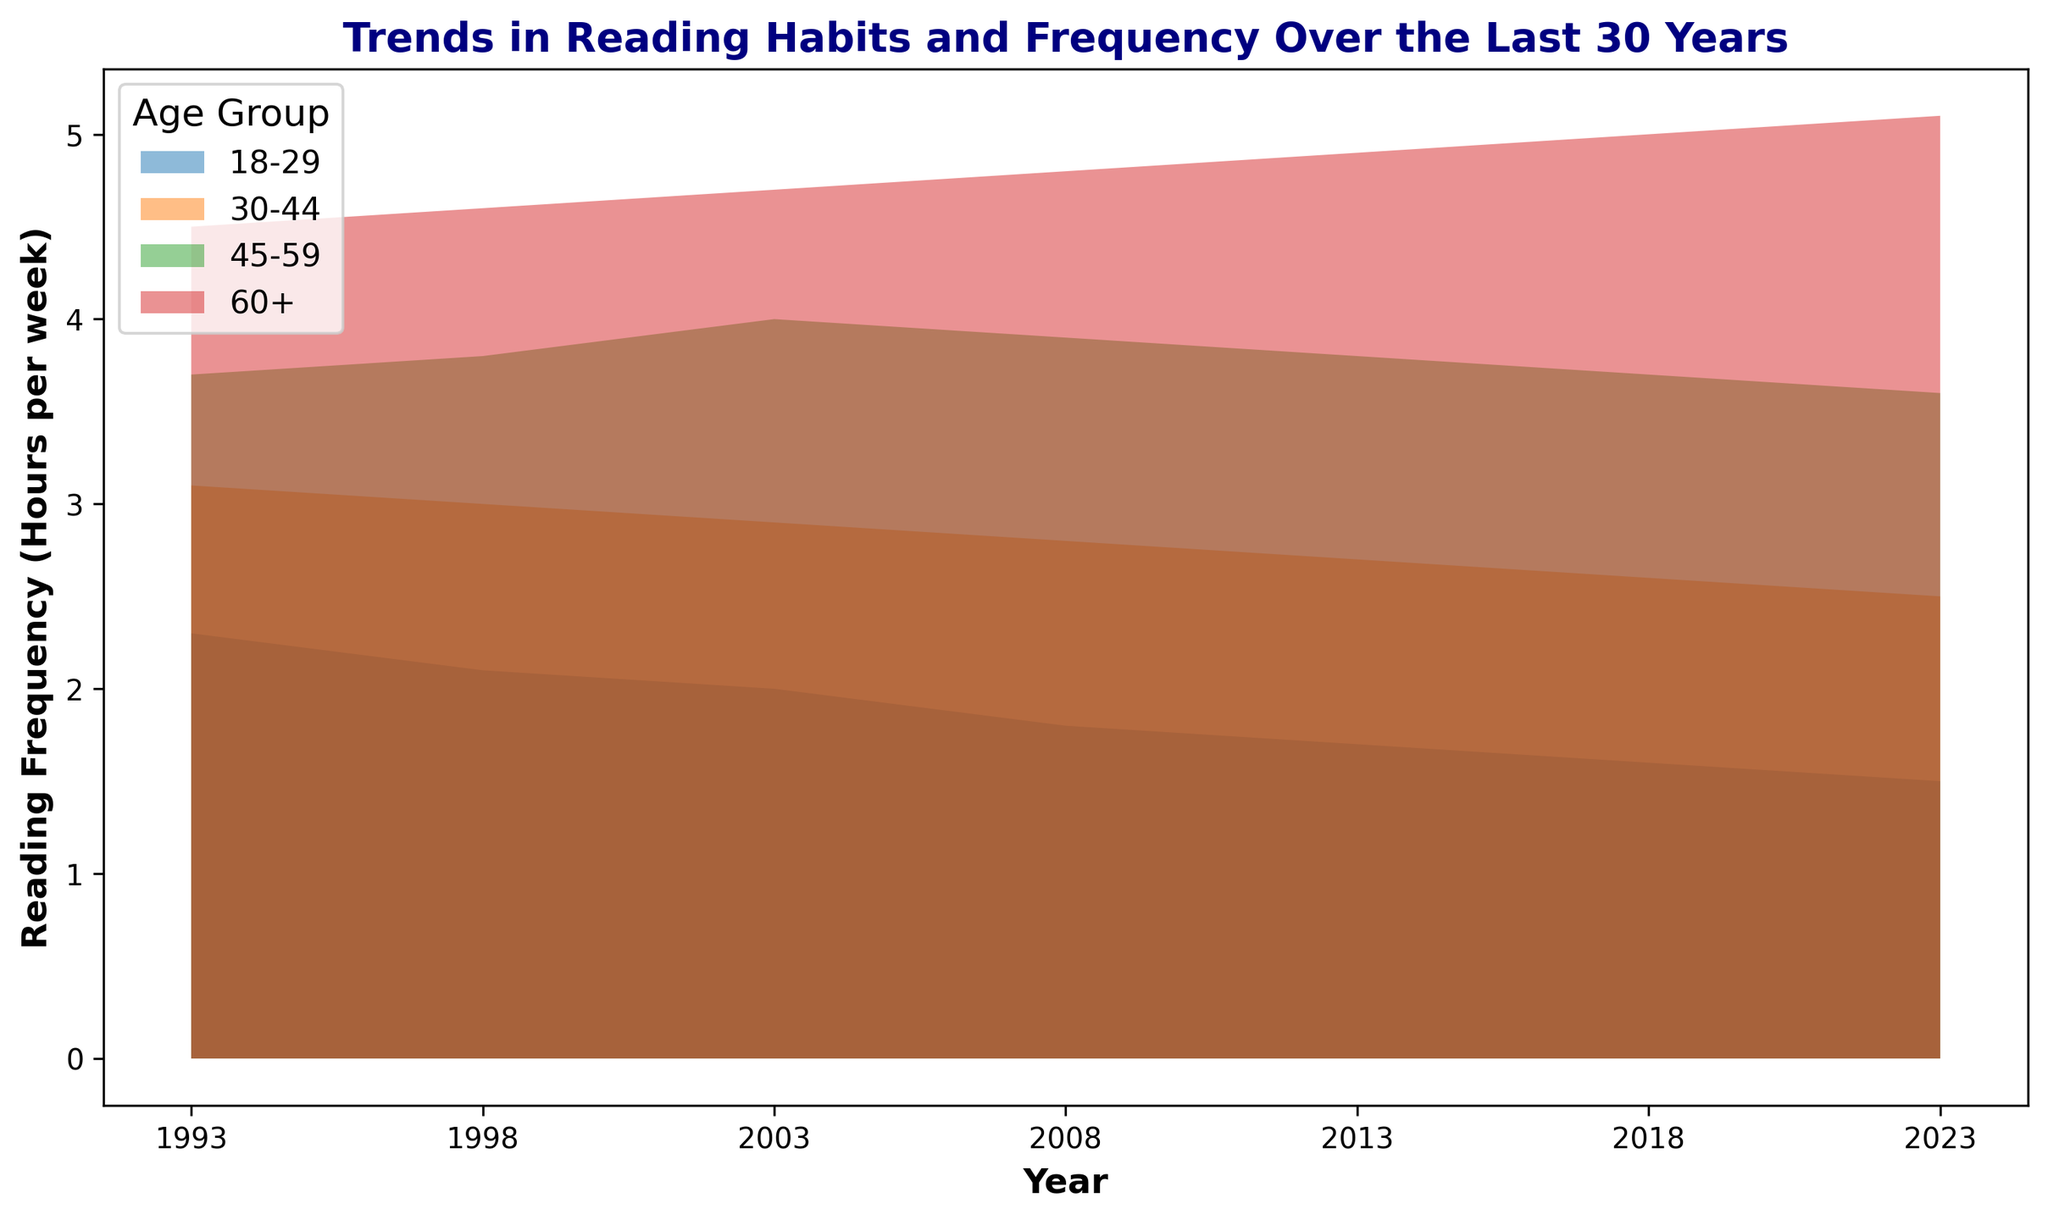Which age group has shown the highest increase in reading frequency over the past 30 years? To find the age group with the highest increase, compare the reading frequency in 1993 and 2023 for each group and calculate the difference. For the age group 60+, the increase is 5.1 - 4.5 = 0.6 hours. Other age groups show decreases or smaller increases.
Answer: 60+ By how many hours has the reading frequency changed for the 18-29 age group from 1993 to 2023? Subtract the reading frequency in 2023 from the reading frequency in 1993 for the 18-29 age group, i.e., 2.3 - 1.5.
Answer: 0.8 hours Which age group consistently reads the most on average over the depicted timeline? Analyze the chart and observe that the 60+ age group maintains the highest reading frequency in each year depicted in the chart.
Answer: 60+ Compare the reading frequency of the 30-44 age group in 1993 to that of the 45-59 age group in 2023. Which is higher? Refer to the chart and compare the values: 3.1 for the 30-44 age group in 1993 and 3.6 for the 45-59 age group in 2023. The latter is higher.
Answer: 45-59 in 2023 What is the trend observed in the 18-29 age group’s reading habits over the years? Is it increasing, decreasing, or stable? The area chart shows a consistent decline in reading frequency for the 18-29 age group from 1993 to 2023.
Answer: Decreasing How has the reading frequency of the 60+ age group changed from 1998 to 2003? What is the difference? Subtract the reading frequency for 60+ in 1998 from that in 2003: 4.7 - 4.6.
Answer: 0.1 hours increase Identify the age group with the smallest change in reading frequency over the 30 years and state the change. Compare the differences from 1993 to 2023 for all age groups. The 45-59 age group shows the smallest change: 3.7 - 3.6 = 0.1 hours.
Answer: 45-59, 0.1 hours Has any age group shown a stable reading frequency with minimal fluctuations over the last 30 years? Examine the filled areas for each age group. The 45-59 age group shows the least fluctuation overall.
Answer: 45-59 Between 2008 and 2018, which age group experienced the greatest decline in reading frequency? View the chart and note the changes for 2008-2018. The 18-29 age group had the greatest decline of 1.8 - 1.6 = 0.2 hours.
Answer: 18-29 